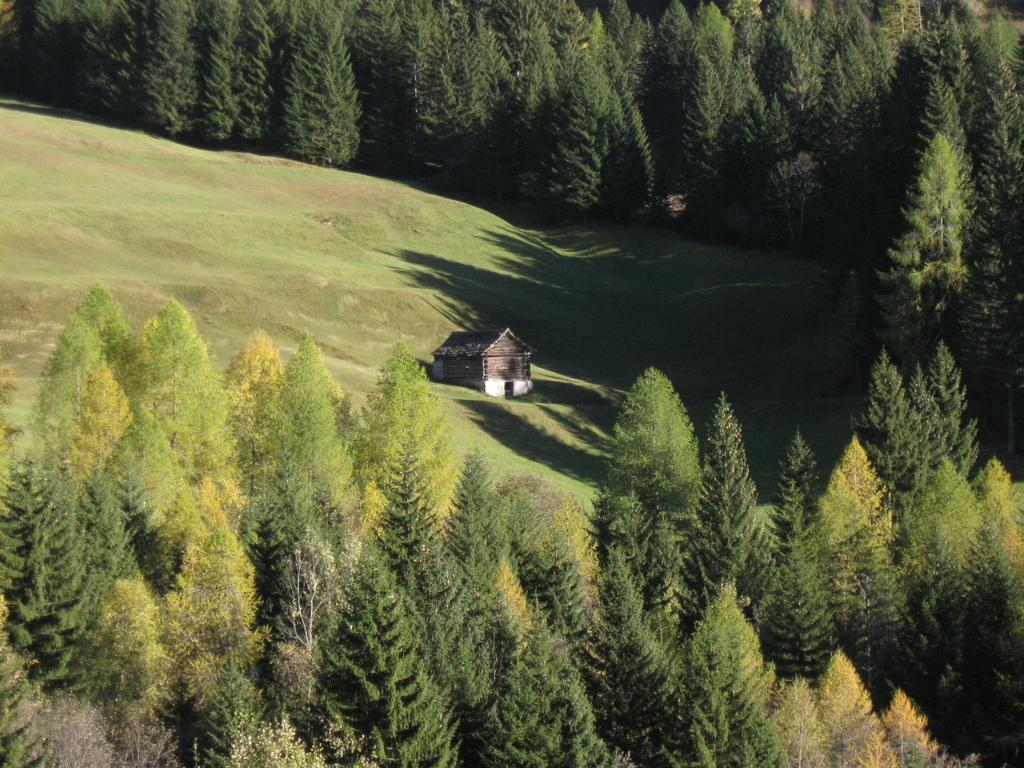What type of structure is visible in the picture? There is a house in the picture. What type of vegetation can be seen in the picture? There are trees in the picture. What type of ground cover is present at the bottom of the picture? There is grass at the bottom of the picture. How many jellyfish can be seen swimming in the grass at the bottom of the picture? There are no jellyfish present in the picture; it features a house, trees, and grass. What type of shellfish is visible in the picture? There is no shellfish present in the picture. 